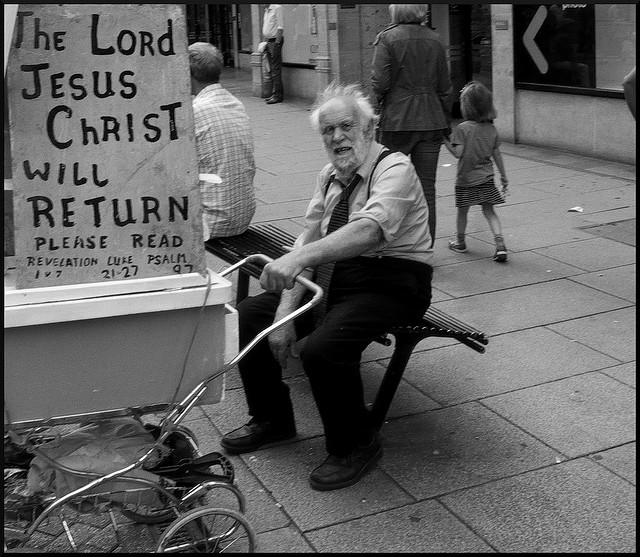What book is the man's sign referencing? Please explain your reasoning. bible. His sign is talking about jesus. 